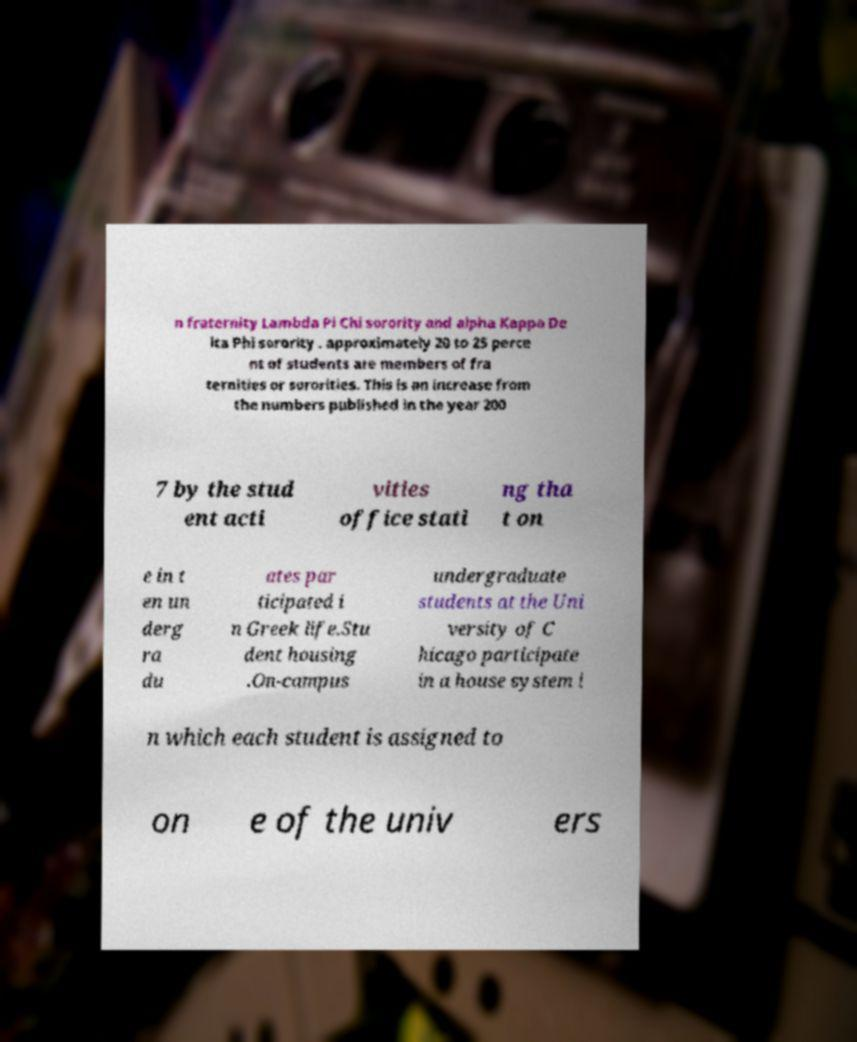Could you assist in decoding the text presented in this image and type it out clearly? n fraternity Lambda Pi Chi sorority and alpha Kappa De lta Phi sorority . approximately 20 to 25 perce nt of students are members of fra ternities or sororities. This is an increase from the numbers published in the year 200 7 by the stud ent acti vities office stati ng tha t on e in t en un derg ra du ates par ticipated i n Greek life.Stu dent housing .On-campus undergraduate students at the Uni versity of C hicago participate in a house system i n which each student is assigned to on e of the univ ers 